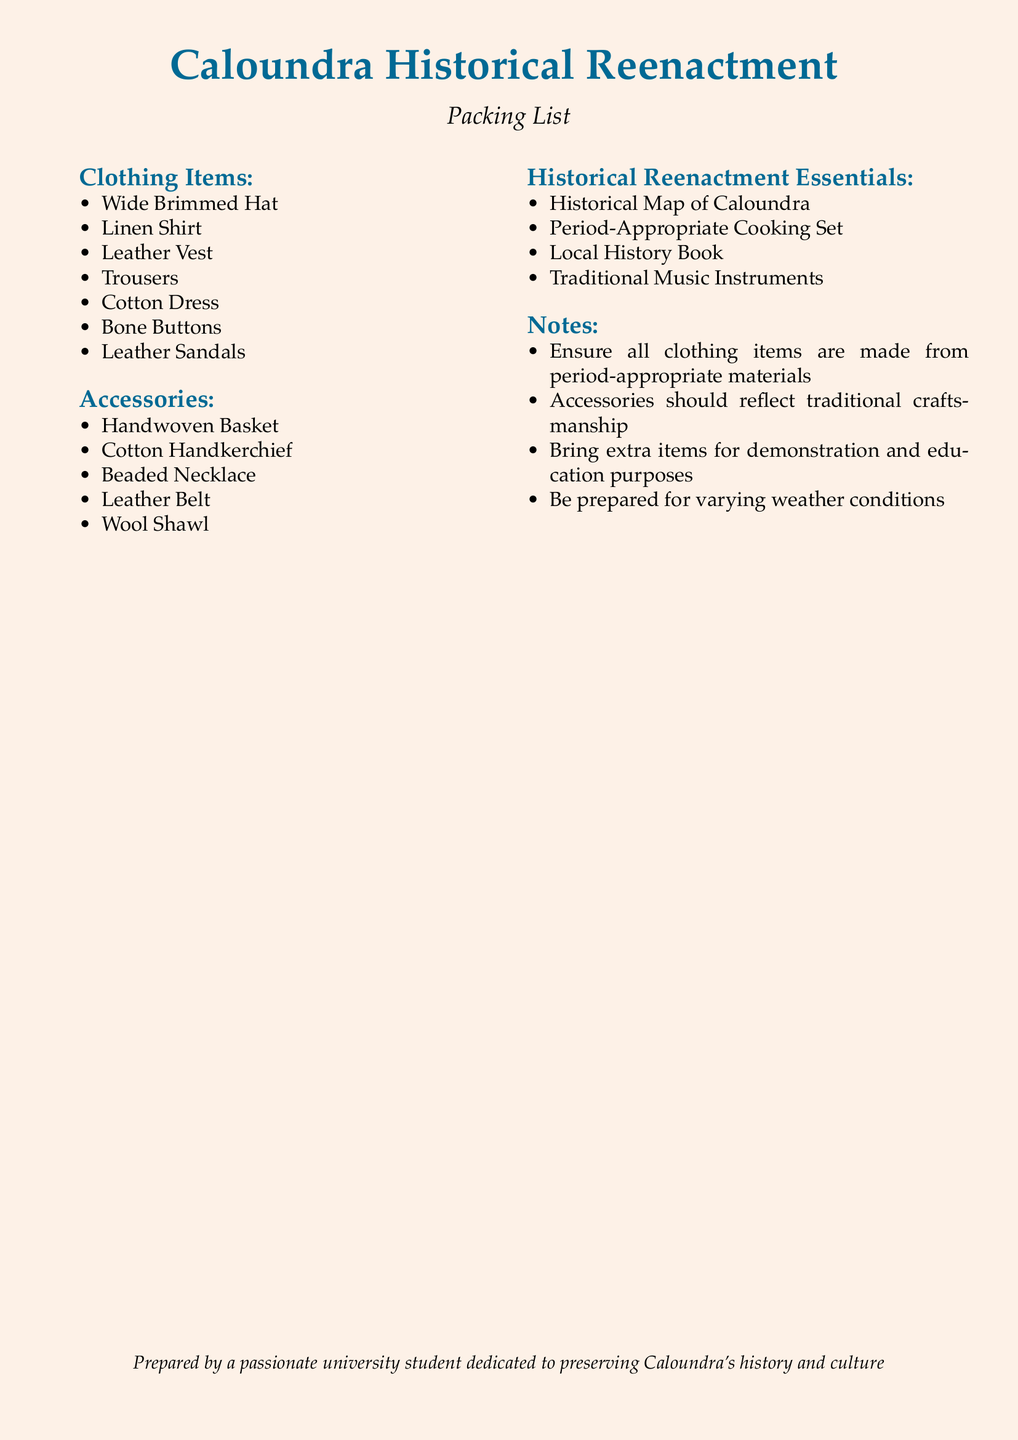What is the title of the document? The title presented in the document is highlighted and indicates the theme of the content, which is "Caloundra Historical Reenactment".
Answer: Caloundra Historical Reenactment How many clothing items are listed? The document includes a section that enumerates clothing items, and by counting them, we can find the total.
Answer: 7 Name one type of accessory mentioned. Accessories are listed in their own section, and picking one from that list provides an example.
Answer: Handwoven Basket What is the color used for section titles? The color used for section titles is specifically defined in the document, which indicates a certain theme.
Answer: seablue What is the purpose of the "Notes" section? The "Notes" section contains important reminders and guidelines concerning the items listed in the document, indicating their significance for historical accuracy and preparation.
Answer: Provide guidelines How many historical reenactment essentials are listed? The list of historical reenactment essentials is provided, and counting these items reveals the total.
Answer: 4 What should all clothing items be made from? The document specifies a requirement for the materials of the clothing items to maintain authenticity.
Answer: period-appropriate materials What does the packing list reflect about the creator? The packing list includes a statement about its creator's dedication to the historical context of Caloundra, showcasing their passion.
Answer: passion for preserving history 